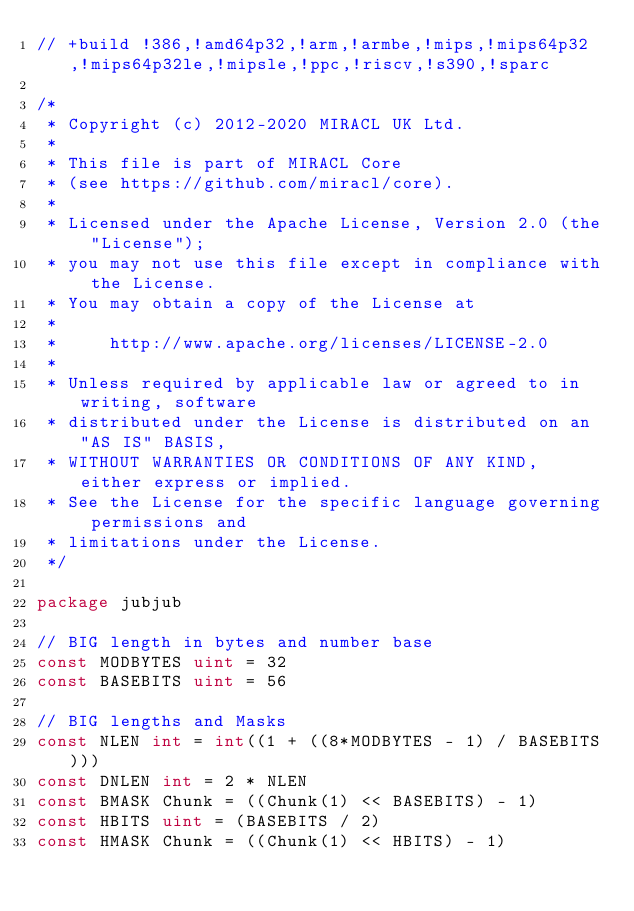<code> <loc_0><loc_0><loc_500><loc_500><_Go_>// +build !386,!amd64p32,!arm,!armbe,!mips,!mips64p32,!mips64p32le,!mipsle,!ppc,!riscv,!s390,!sparc

/*
 * Copyright (c) 2012-2020 MIRACL UK Ltd.
 *
 * This file is part of MIRACL Core
 * (see https://github.com/miracl/core).
 *
 * Licensed under the Apache License, Version 2.0 (the "License");
 * you may not use this file except in compliance with the License.
 * You may obtain a copy of the License at
 *
 *     http://www.apache.org/licenses/LICENSE-2.0
 *
 * Unless required by applicable law or agreed to in writing, software
 * distributed under the License is distributed on an "AS IS" BASIS,
 * WITHOUT WARRANTIES OR CONDITIONS OF ANY KIND, either express or implied.
 * See the License for the specific language governing permissions and
 * limitations under the License.
 */

package jubjub

// BIG length in bytes and number base
const MODBYTES uint = 32
const BASEBITS uint = 56

// BIG lengths and Masks
const NLEN int = int((1 + ((8*MODBYTES - 1) / BASEBITS)))
const DNLEN int = 2 * NLEN
const BMASK Chunk = ((Chunk(1) << BASEBITS) - 1)
const HBITS uint = (BASEBITS / 2)
const HMASK Chunk = ((Chunk(1) << HBITS) - 1)</code> 